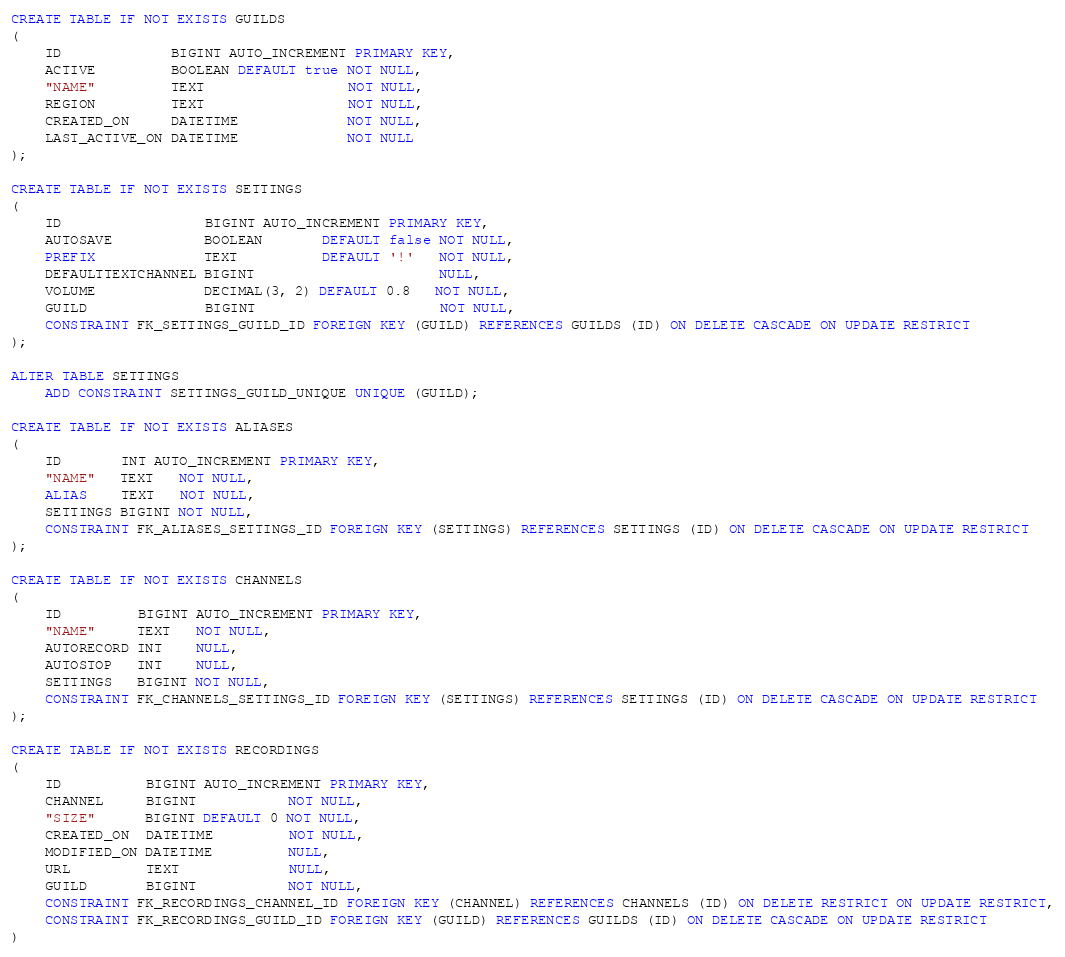Convert code to text. <code><loc_0><loc_0><loc_500><loc_500><_SQL_>CREATE TABLE IF NOT EXISTS GUILDS
(
    ID             BIGINT AUTO_INCREMENT PRIMARY KEY,
    ACTIVE         BOOLEAN DEFAULT true NOT NULL,
    "NAME"         TEXT                 NOT NULL,
    REGION         TEXT                 NOT NULL,
    CREATED_ON     DATETIME             NOT NULL,
    LAST_ACTIVE_ON DATETIME             NOT NULL
);

CREATE TABLE IF NOT EXISTS SETTINGS
(
    ID                 BIGINT AUTO_INCREMENT PRIMARY KEY,
    AUTOSAVE           BOOLEAN       DEFAULT false NOT NULL,
    PREFIX             TEXT          DEFAULT '!'   NOT NULL,
    DEFAULTTEXTCHANNEL BIGINT                      NULL,
    VOLUME             DECIMAL(3, 2) DEFAULT 0.8   NOT NULL,
    GUILD              BIGINT                      NOT NULL,
    CONSTRAINT FK_SETTINGS_GUILD_ID FOREIGN KEY (GUILD) REFERENCES GUILDS (ID) ON DELETE CASCADE ON UPDATE RESTRICT
);

ALTER TABLE SETTINGS
    ADD CONSTRAINT SETTINGS_GUILD_UNIQUE UNIQUE (GUILD);

CREATE TABLE IF NOT EXISTS ALIASES
(
    ID       INT AUTO_INCREMENT PRIMARY KEY,
    "NAME"   TEXT   NOT NULL,
    ALIAS    TEXT   NOT NULL,
    SETTINGS BIGINT NOT NULL,
    CONSTRAINT FK_ALIASES_SETTINGS_ID FOREIGN KEY (SETTINGS) REFERENCES SETTINGS (ID) ON DELETE CASCADE ON UPDATE RESTRICT
);

CREATE TABLE IF NOT EXISTS CHANNELS
(
    ID         BIGINT AUTO_INCREMENT PRIMARY KEY,
    "NAME"     TEXT   NOT NULL,
    AUTORECORD INT    NULL,
    AUTOSTOP   INT    NULL,
    SETTINGS   BIGINT NOT NULL,
    CONSTRAINT FK_CHANNELS_SETTINGS_ID FOREIGN KEY (SETTINGS) REFERENCES SETTINGS (ID) ON DELETE CASCADE ON UPDATE RESTRICT
);

CREATE TABLE IF NOT EXISTS RECORDINGS
(
    ID          BIGINT AUTO_INCREMENT PRIMARY KEY,
    CHANNEL     BIGINT           NOT NULL,
    "SIZE"      BIGINT DEFAULT 0 NOT NULL,
    CREATED_ON  DATETIME         NOT NULL,
    MODIFIED_ON DATETIME         NULL,
    URL         TEXT             NULL,
    GUILD       BIGINT           NOT NULL,
    CONSTRAINT FK_RECORDINGS_CHANNEL_ID FOREIGN KEY (CHANNEL) REFERENCES CHANNELS (ID) ON DELETE RESTRICT ON UPDATE RESTRICT,
    CONSTRAINT FK_RECORDINGS_GUILD_ID FOREIGN KEY (GUILD) REFERENCES GUILDS (ID) ON DELETE CASCADE ON UPDATE RESTRICT
)
</code> 